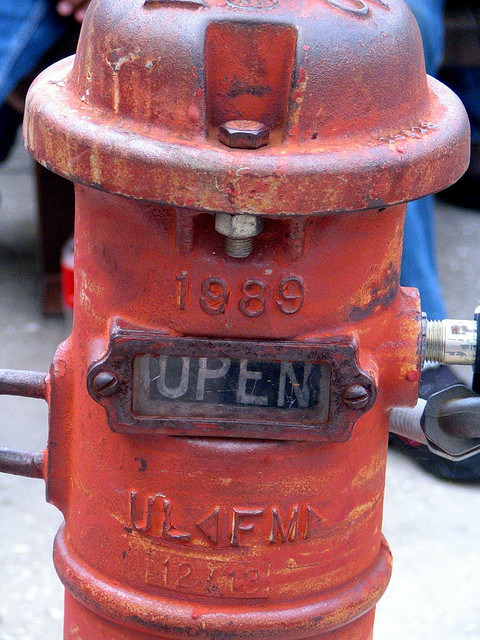Identify and read out the text in this image. 1989 OPEN UL FMN 12 / 13 